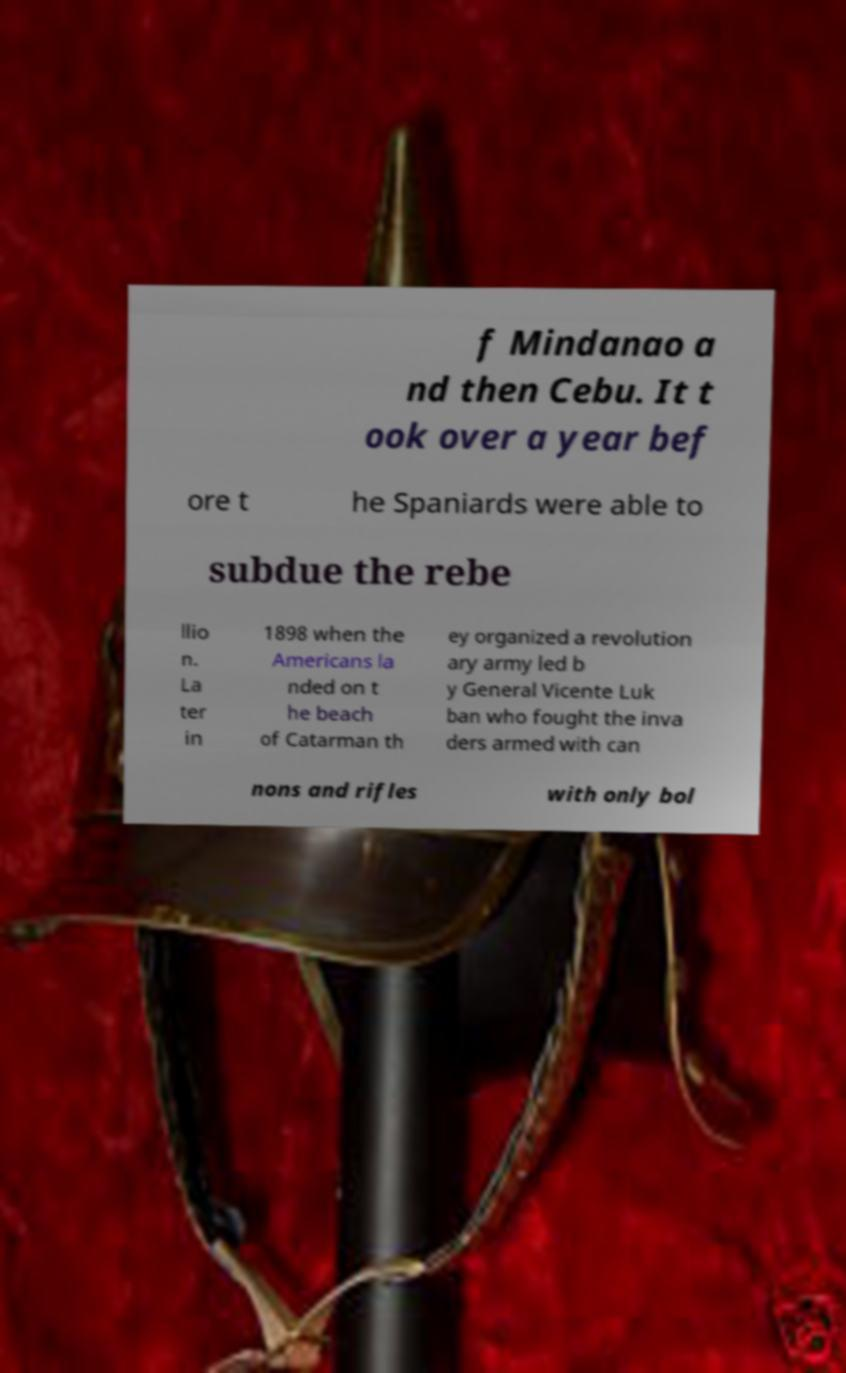For documentation purposes, I need the text within this image transcribed. Could you provide that? f Mindanao a nd then Cebu. It t ook over a year bef ore t he Spaniards were able to subdue the rebe llio n. La ter in 1898 when the Americans la nded on t he beach of Catarman th ey organized a revolution ary army led b y General Vicente Luk ban who fought the inva ders armed with can nons and rifles with only bol 